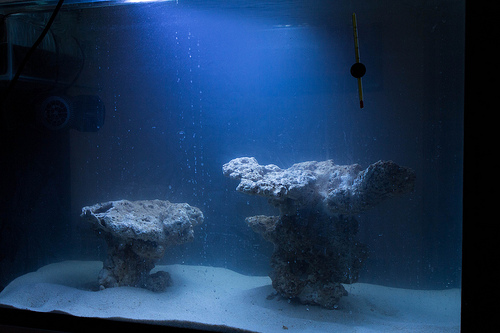<image>
Can you confirm if the rock is in front of the water? No. The rock is not in front of the water. The spatial positioning shows a different relationship between these objects. 